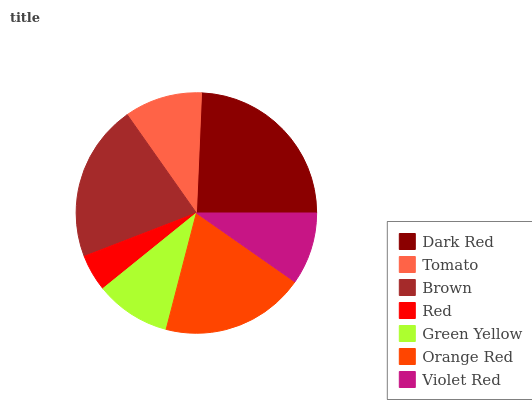Is Red the minimum?
Answer yes or no. Yes. Is Dark Red the maximum?
Answer yes or no. Yes. Is Tomato the minimum?
Answer yes or no. No. Is Tomato the maximum?
Answer yes or no. No. Is Dark Red greater than Tomato?
Answer yes or no. Yes. Is Tomato less than Dark Red?
Answer yes or no. Yes. Is Tomato greater than Dark Red?
Answer yes or no. No. Is Dark Red less than Tomato?
Answer yes or no. No. Is Tomato the high median?
Answer yes or no. Yes. Is Tomato the low median?
Answer yes or no. Yes. Is Dark Red the high median?
Answer yes or no. No. Is Orange Red the low median?
Answer yes or no. No. 